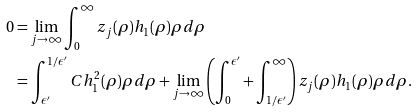Convert formula to latex. <formula><loc_0><loc_0><loc_500><loc_500>0 & = \lim _ { j \to \infty } \int _ { 0 } ^ { \infty } z _ { j } ( \rho ) h _ { 1 } ( \rho ) \rho d \rho \\ & = \int _ { \epsilon ^ { \prime } } ^ { 1 / \epsilon ^ { \prime } } C h _ { 1 } ^ { 2 } ( \rho ) \rho d \rho + \lim _ { j \to \infty } \left ( \int _ { 0 } ^ { \epsilon ^ { \prime } } + \int _ { 1 / \epsilon ^ { \prime } } ^ { \infty } \right ) z _ { j } ( \rho ) h _ { 1 } ( \rho ) \rho d \rho .</formula> 